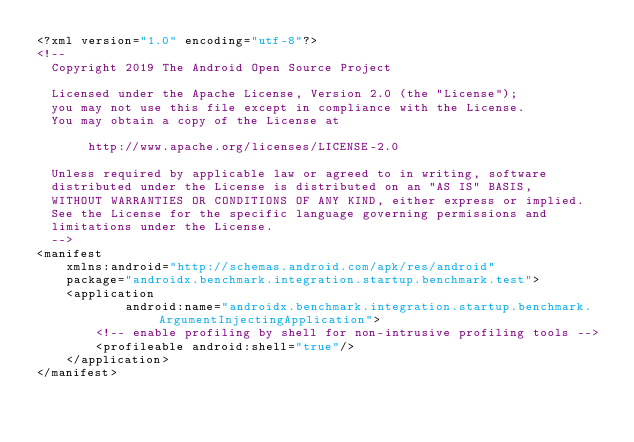<code> <loc_0><loc_0><loc_500><loc_500><_XML_><?xml version="1.0" encoding="utf-8"?>
<!--
  Copyright 2019 The Android Open Source Project

  Licensed under the Apache License, Version 2.0 (the "License");
  you may not use this file except in compliance with the License.
  You may obtain a copy of the License at

       http://www.apache.org/licenses/LICENSE-2.0

  Unless required by applicable law or agreed to in writing, software
  distributed under the License is distributed on an "AS IS" BASIS,
  WITHOUT WARRANTIES OR CONDITIONS OF ANY KIND, either express or implied.
  See the License for the specific language governing permissions and
  limitations under the License.
  -->
<manifest
    xmlns:android="http://schemas.android.com/apk/res/android"
    package="androidx.benchmark.integration.startup.benchmark.test">
    <application
            android:name="androidx.benchmark.integration.startup.benchmark.ArgumentInjectingApplication">
        <!-- enable profiling by shell for non-intrusive profiling tools -->
        <profileable android:shell="true"/>
    </application>
</manifest>
</code> 